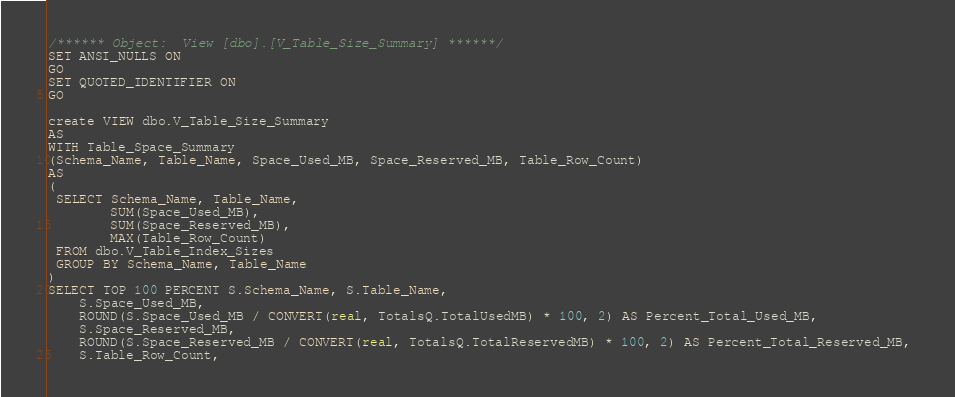Convert code to text. <code><loc_0><loc_0><loc_500><loc_500><_SQL_>/****** Object:  View [dbo].[V_Table_Size_Summary] ******/
SET ANSI_NULLS ON
GO
SET QUOTED_IDENTIFIER ON
GO

create VIEW dbo.V_Table_Size_Summary
AS
WITH Table_Space_Summary
(Schema_Name, Table_Name, Space_Used_MB, Space_Reserved_MB, Table_Row_Count)
AS
(
 SELECT Schema_Name, Table_Name, 
       	SUM(Space_Used_MB), 
		SUM(Space_Reserved_MB), 
		MAX(Table_Row_Count)
 FROM dbo.V_Table_Index_Sizes
 GROUP BY Schema_Name, Table_Name
)
SELECT TOP 100 PERCENT S.Schema_Name, S.Table_Name,
	S.Space_Used_MB,
    ROUND(S.Space_Used_MB / CONVERT(real, TotalsQ.TotalUsedMB) * 100, 2) AS Percent_Total_Used_MB, 
	S.Space_Reserved_MB,
    ROUND(S.Space_Reserved_MB / CONVERT(real, TotalsQ.TotalReservedMB) * 100, 2) AS Percent_Total_Reserved_MB, 
    S.Table_Row_Count, </code> 